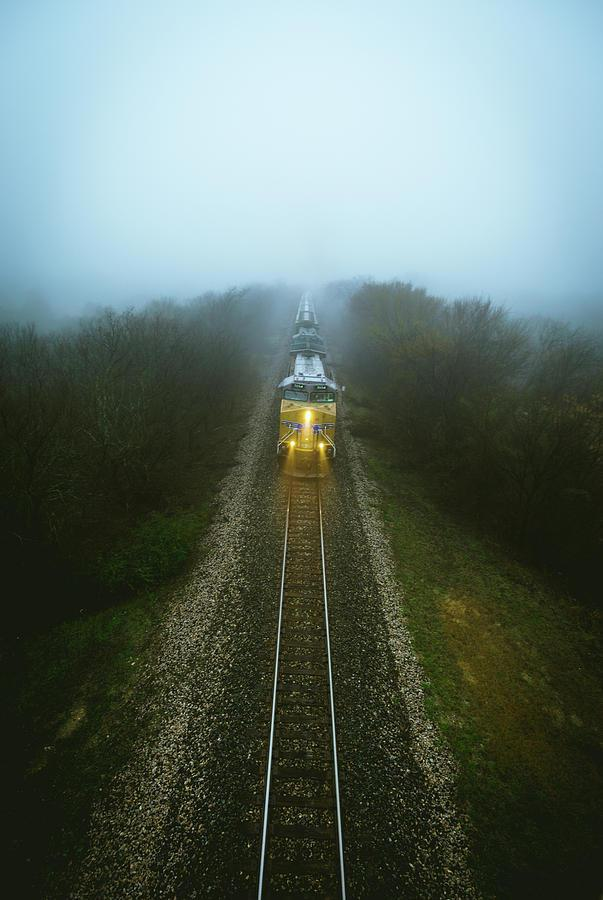Is there a train in the image? Yes, there is a train centered in the image, captured on a railroad track surrounded by vegetation and enveloped in a light layer of fog, which adds a sense of mystique to the scene. 